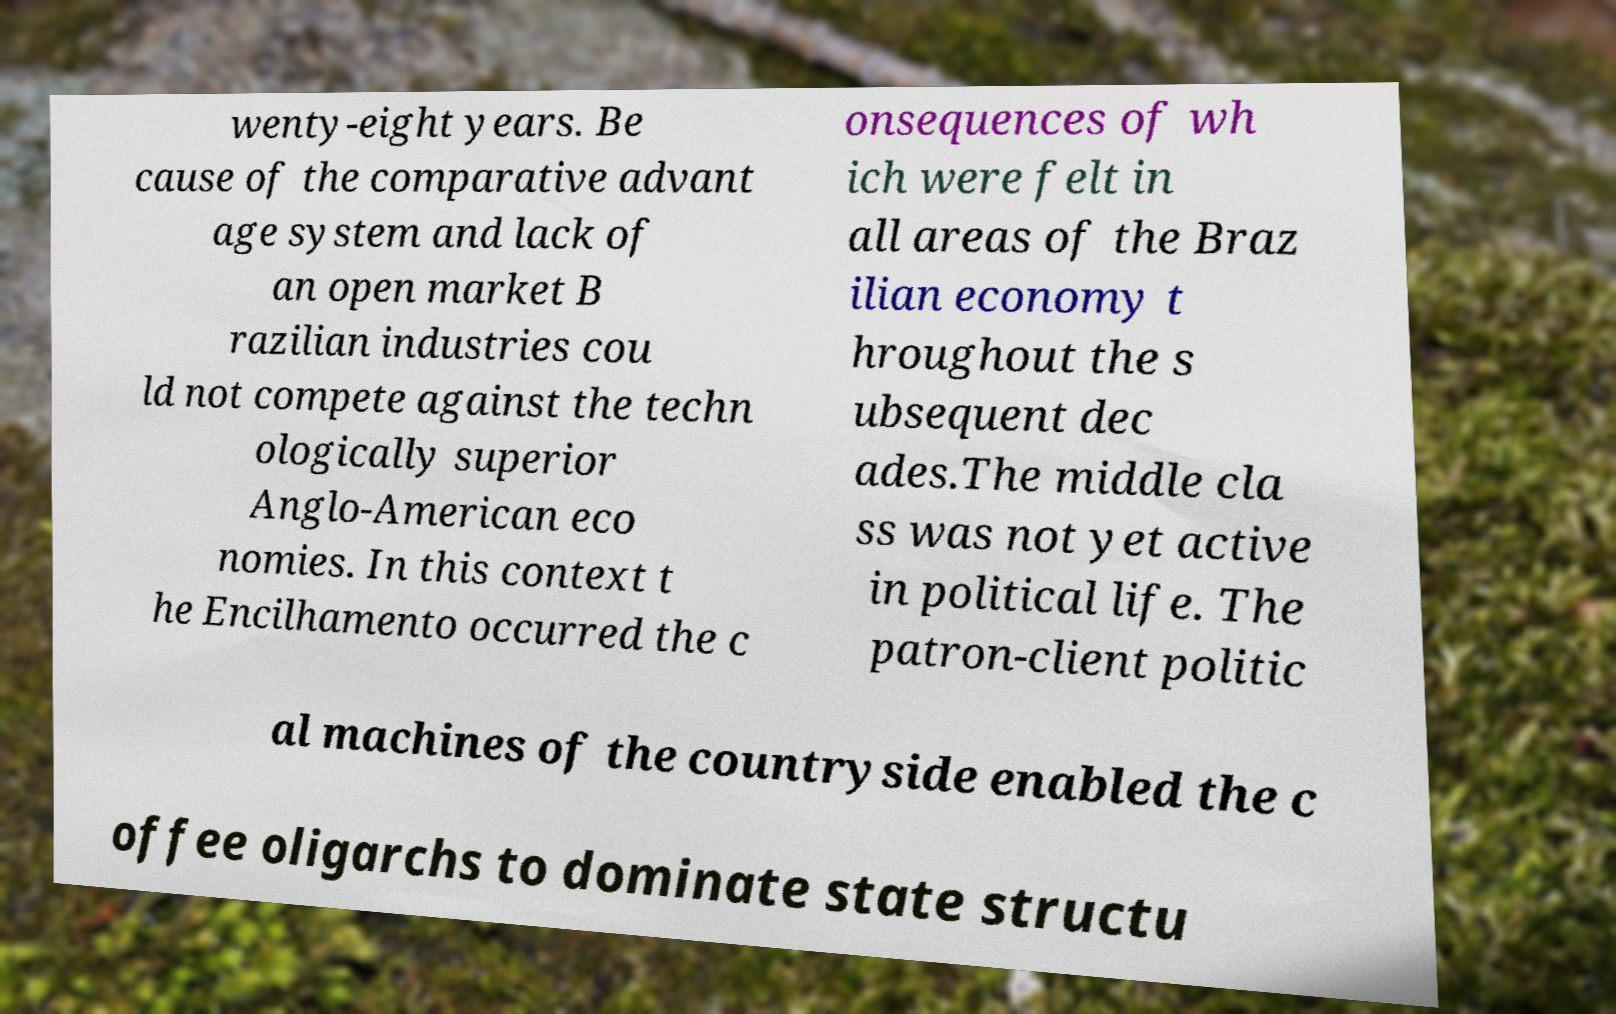Please identify and transcribe the text found in this image. wenty-eight years. Be cause of the comparative advant age system and lack of an open market B razilian industries cou ld not compete against the techn ologically superior Anglo-American eco nomies. In this context t he Encilhamento occurred the c onsequences of wh ich were felt in all areas of the Braz ilian economy t hroughout the s ubsequent dec ades.The middle cla ss was not yet active in political life. The patron-client politic al machines of the countryside enabled the c offee oligarchs to dominate state structu 